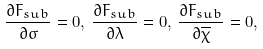<formula> <loc_0><loc_0><loc_500><loc_500>\frac { \partial F _ { s u b } } { \partial \sigma } = 0 , \, \frac { \partial F _ { s u b } } { \partial \lambda } = 0 , \, \frac { \partial F _ { s u b } } { \partial \overline { \chi } } = 0 ,</formula> 